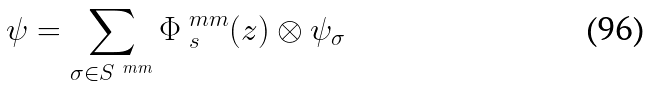Convert formula to latex. <formula><loc_0><loc_0><loc_500><loc_500>\psi = \sum _ { \sigma \in S ^ { \ m m } } \Phi _ { \ s } ^ { \ m m } ( z ) \otimes \psi _ { \sigma }</formula> 